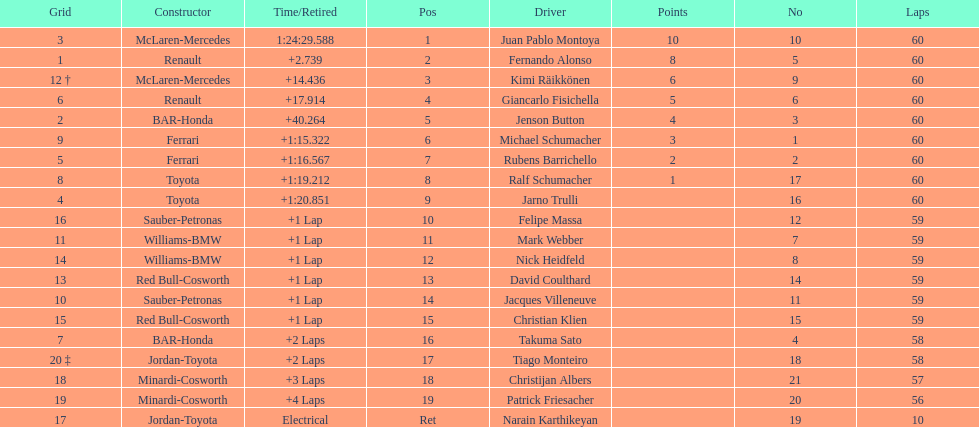What is the number of toyota's on the list? 4. 